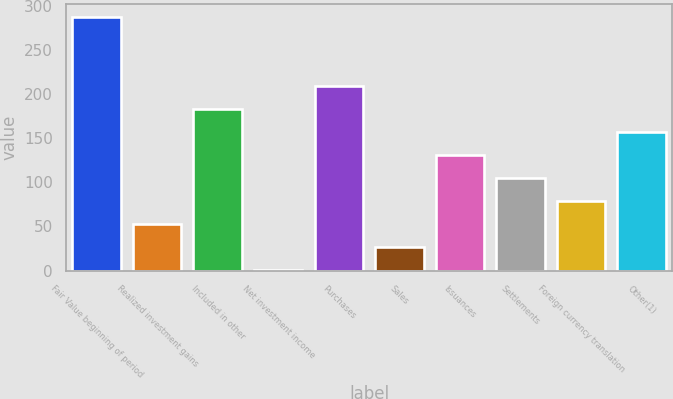<chart> <loc_0><loc_0><loc_500><loc_500><bar_chart><fcel>Fair Value beginning of period<fcel>Realized investment gains<fcel>Included in other<fcel>Net investment income<fcel>Purchases<fcel>Sales<fcel>Issuances<fcel>Settlements<fcel>Foreign currency translation<fcel>Other(1)<nl><fcel>287<fcel>53<fcel>183<fcel>1<fcel>209<fcel>27<fcel>131<fcel>105<fcel>79<fcel>157<nl></chart> 